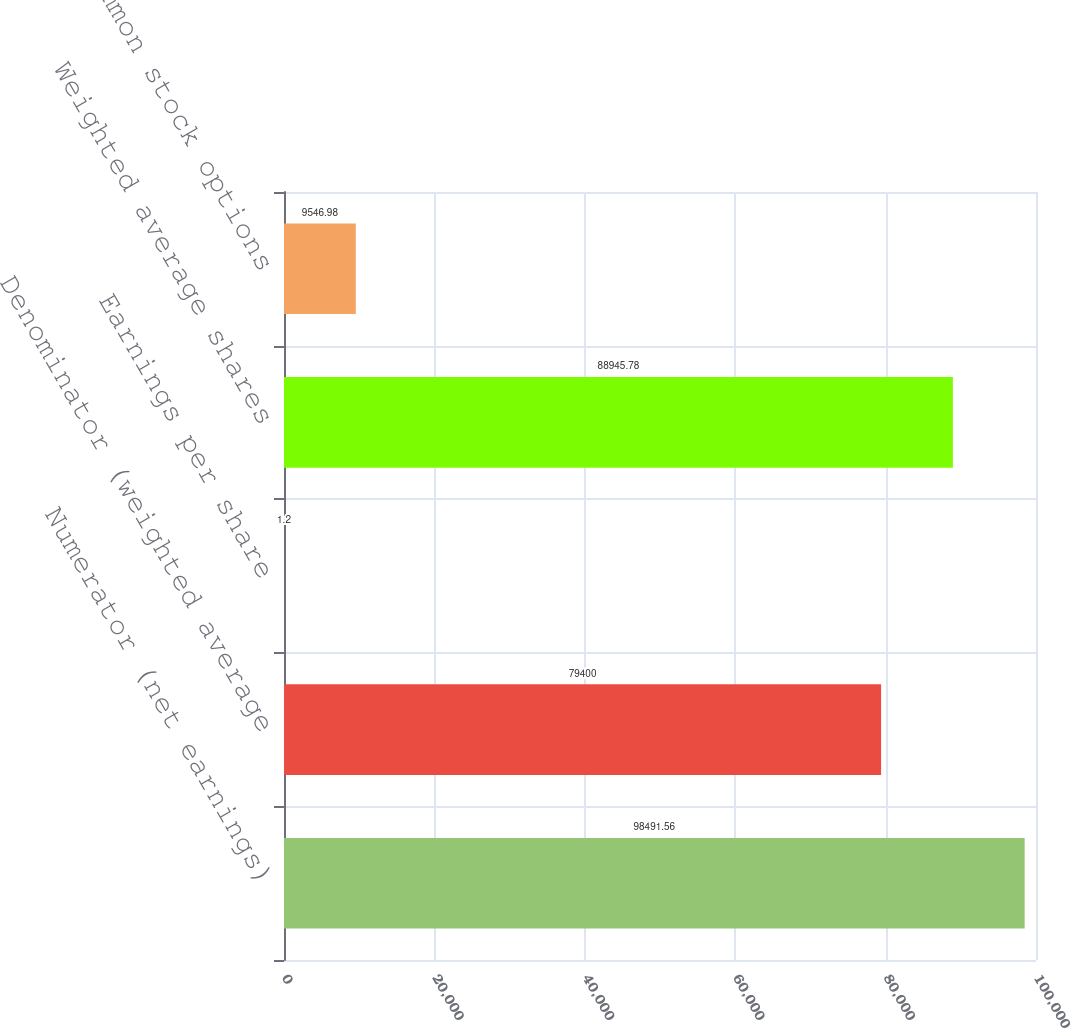Convert chart to OTSL. <chart><loc_0><loc_0><loc_500><loc_500><bar_chart><fcel>Numerator (net earnings)<fcel>Denominator (weighted average<fcel>Earnings per share<fcel>Weighted average shares<fcel>Effect of common stock options<nl><fcel>98491.6<fcel>79400<fcel>1.2<fcel>88945.8<fcel>9546.98<nl></chart> 